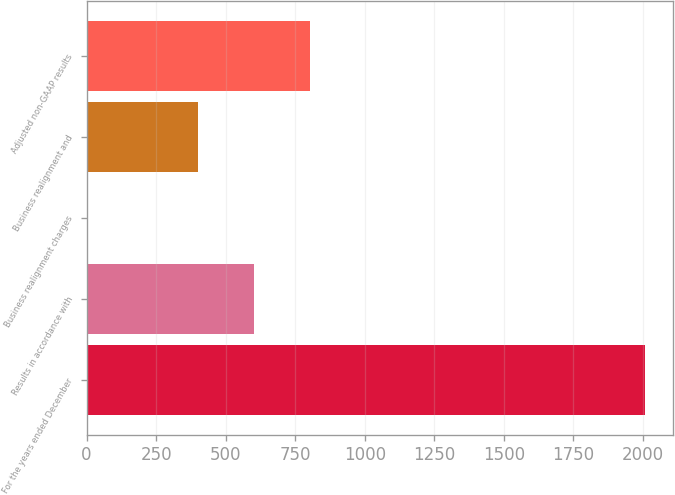Convert chart to OTSL. <chart><loc_0><loc_0><loc_500><loc_500><bar_chart><fcel>For the years ended December<fcel>Results in accordance with<fcel>Business realignment charges<fcel>Business realignment and<fcel>Adjusted non-GAAP results<nl><fcel>2009<fcel>602.72<fcel>0.02<fcel>401.82<fcel>803.62<nl></chart> 